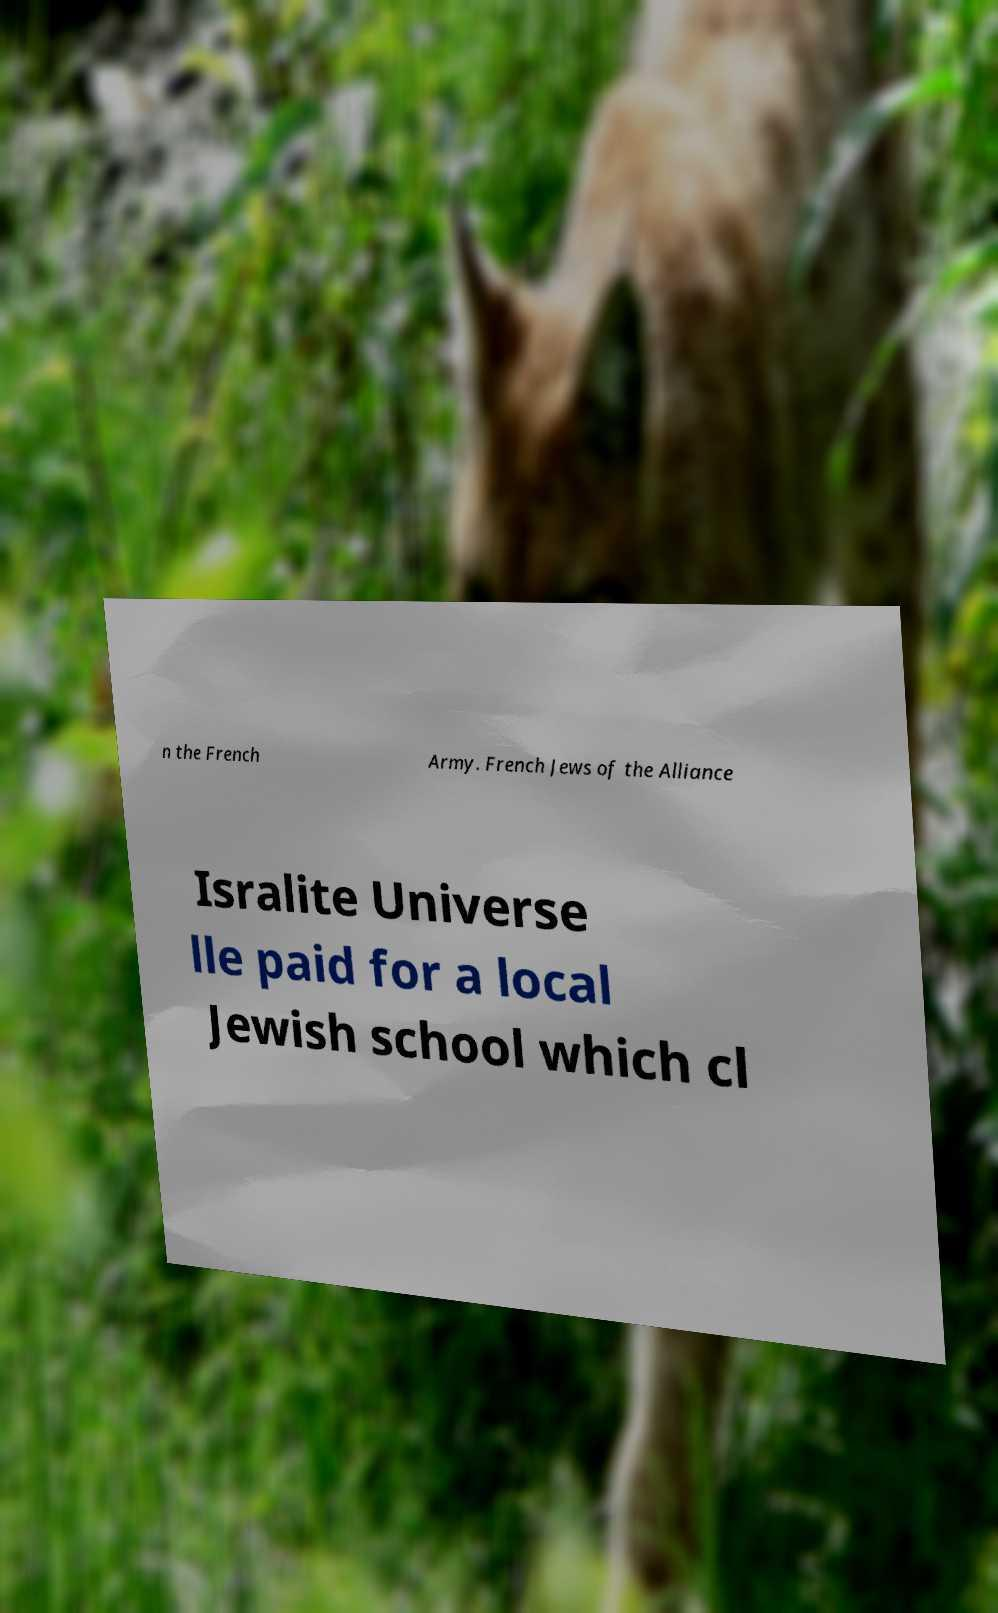I need the written content from this picture converted into text. Can you do that? n the French Army. French Jews of the Alliance Isralite Universe lle paid for a local Jewish school which cl 